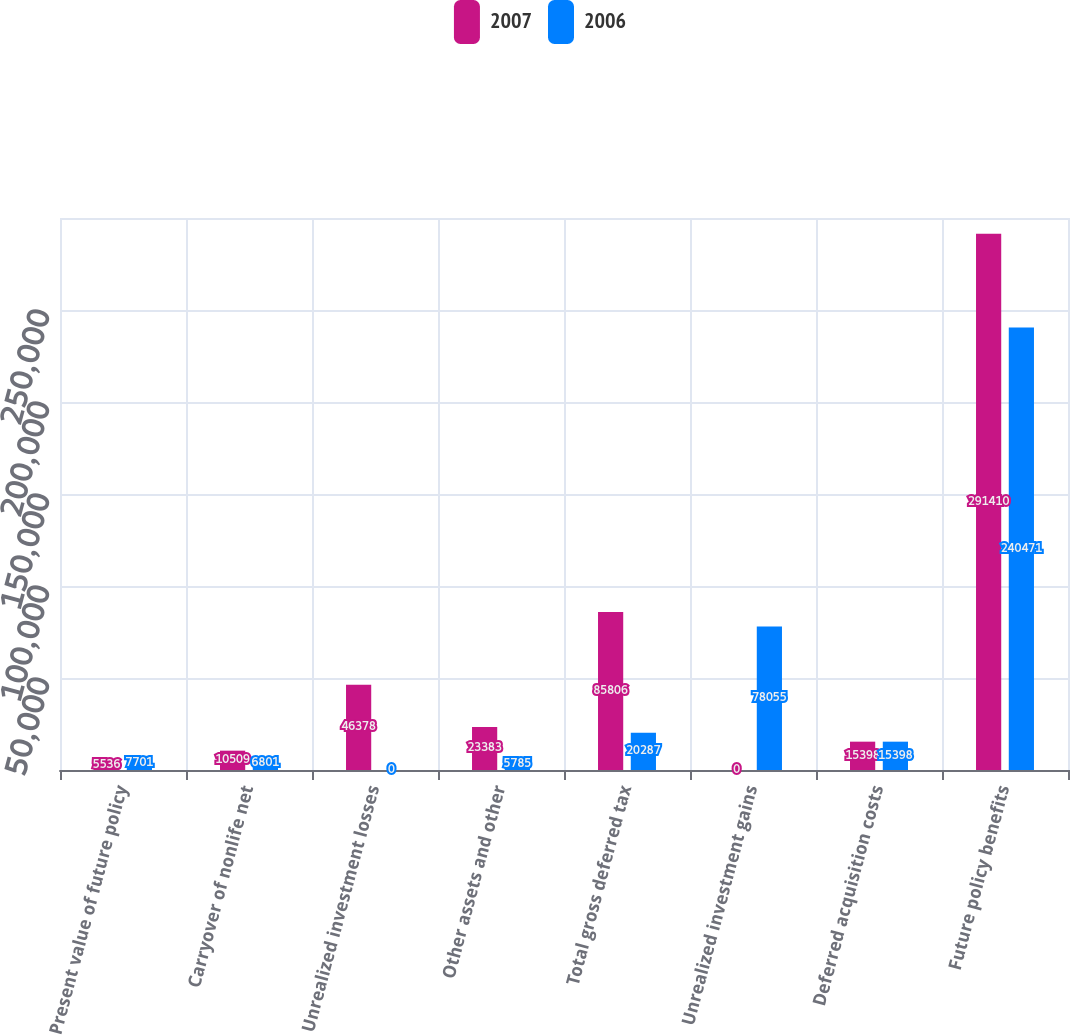Convert chart to OTSL. <chart><loc_0><loc_0><loc_500><loc_500><stacked_bar_chart><ecel><fcel>Present value of future policy<fcel>Carryover of nonlife net<fcel>Unrealized investment losses<fcel>Other assets and other<fcel>Total gross deferred tax<fcel>Unrealized investment gains<fcel>Deferred acquisition costs<fcel>Future policy benefits<nl><fcel>2007<fcel>5536<fcel>10509<fcel>46378<fcel>23383<fcel>85806<fcel>0<fcel>15398<fcel>291410<nl><fcel>2006<fcel>7701<fcel>6801<fcel>0<fcel>5785<fcel>20287<fcel>78055<fcel>15398<fcel>240471<nl></chart> 